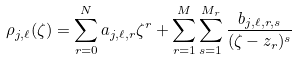<formula> <loc_0><loc_0><loc_500><loc_500>\rho _ { j , \ell } ( \zeta ) = \sum _ { r = 0 } ^ { N } a _ { j , \ell , r } \zeta ^ { r } + \sum _ { r = 1 } ^ { M } \sum _ { s = 1 } ^ { M _ { r } } \frac { b _ { j , \ell , r , s } } { ( \zeta - z _ { r } ) ^ { s } }</formula> 